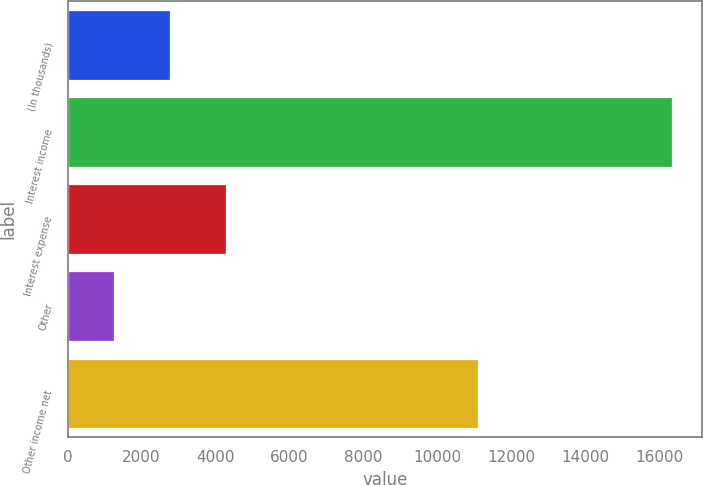<chart> <loc_0><loc_0><loc_500><loc_500><bar_chart><fcel>(In thousands)<fcel>Interest income<fcel>Interest expense<fcel>Other<fcel>Other income net<nl><fcel>2767.3<fcel>16342<fcel>4275.6<fcel>1259<fcel>11090<nl></chart> 